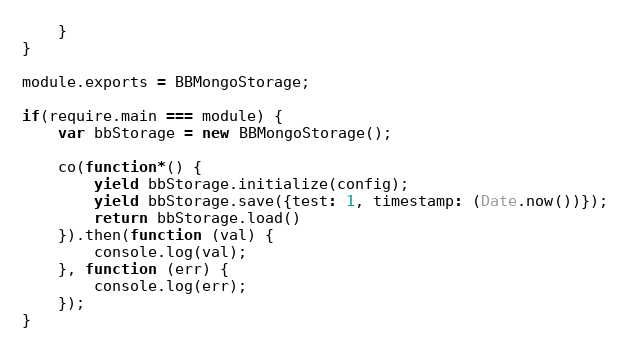<code> <loc_0><loc_0><loc_500><loc_500><_JavaScript_>    }
}

module.exports = BBMongoStorage;

if(require.main === module) {
    var bbStorage = new BBMongoStorage();

    co(function*() {
        yield bbStorage.initialize(config);
        yield bbStorage.save({test: 1, timestamp: (Date.now())});
        return bbStorage.load()
    }).then(function (val) {
        console.log(val);
    }, function (err) {
        console.log(err);
    });
}</code> 